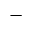Convert formula to latex. <formula><loc_0><loc_0><loc_500><loc_500>-</formula> 